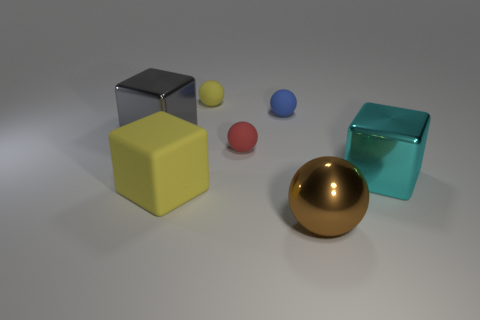There is a large object left of the yellow object to the left of the tiny yellow rubber ball; what number of large cyan cubes are behind it?
Ensure brevity in your answer.  0. There is a brown thing in front of the large yellow block; is it the same shape as the cyan thing?
Provide a short and direct response. No. What number of things are big brown things or big metallic blocks that are on the left side of the shiny sphere?
Offer a very short reply. 2. Are there more tiny blue matte things to the left of the yellow matte block than small blue metallic cylinders?
Offer a very short reply. No. Are there the same number of brown metallic things that are to the left of the tiny blue thing and tiny red objects right of the big gray metallic object?
Your answer should be very brief. No. There is a big shiny object in front of the cyan object; is there a big metal sphere that is behind it?
Provide a short and direct response. No. What is the shape of the big cyan object?
Your response must be concise. Cube. The other object that is the same color as the big rubber thing is what size?
Provide a short and direct response. Small. What is the size of the metal object behind the tiny ball in front of the tiny blue sphere?
Give a very brief answer. Large. What size is the block that is behind the large cyan metallic thing?
Provide a succinct answer. Large. 